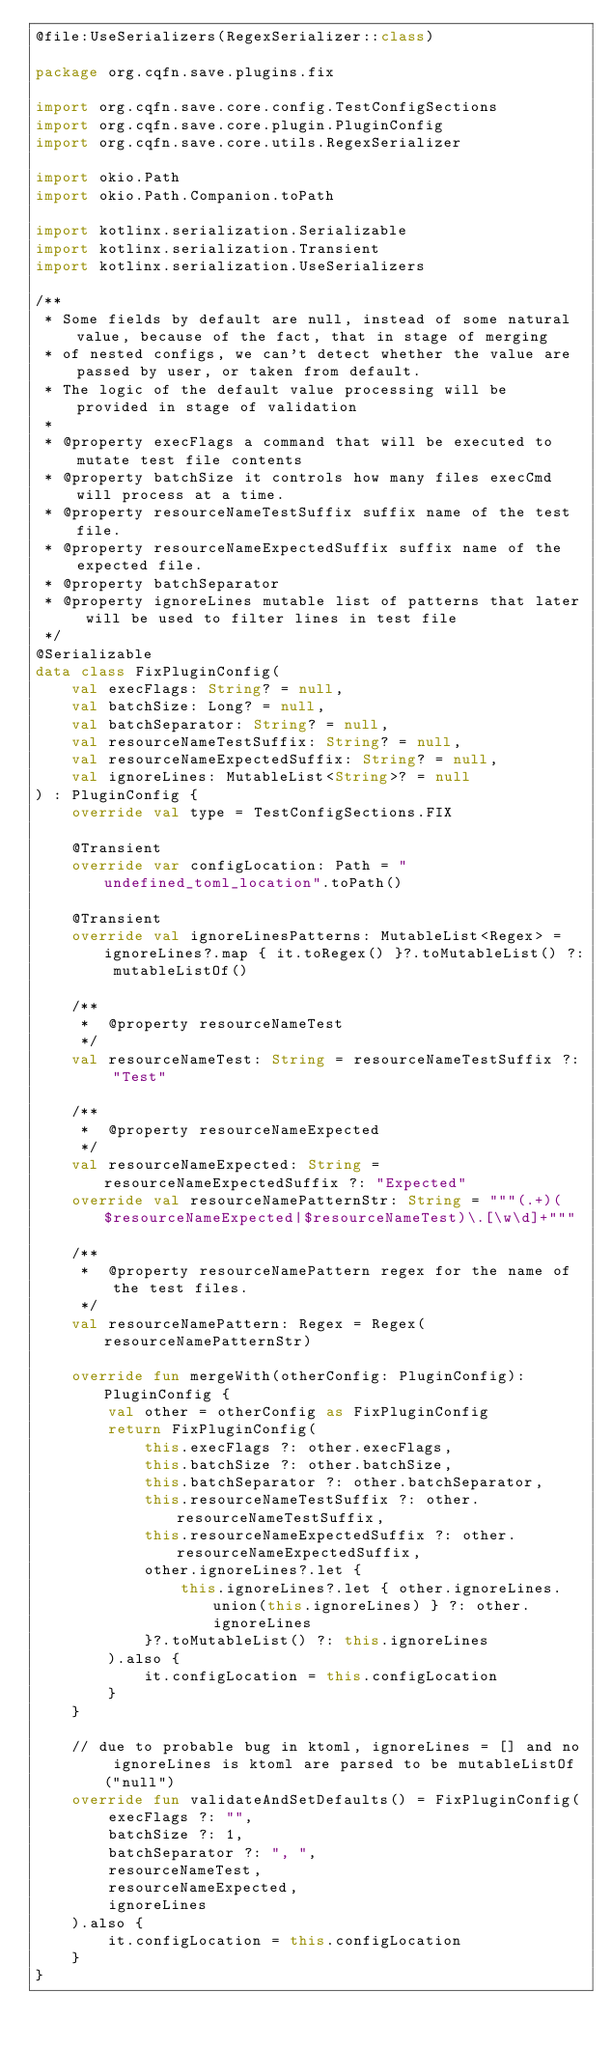<code> <loc_0><loc_0><loc_500><loc_500><_Kotlin_>@file:UseSerializers(RegexSerializer::class)

package org.cqfn.save.plugins.fix

import org.cqfn.save.core.config.TestConfigSections
import org.cqfn.save.core.plugin.PluginConfig
import org.cqfn.save.core.utils.RegexSerializer

import okio.Path
import okio.Path.Companion.toPath

import kotlinx.serialization.Serializable
import kotlinx.serialization.Transient
import kotlinx.serialization.UseSerializers

/**
 * Some fields by default are null, instead of some natural value, because of the fact, that in stage of merging
 * of nested configs, we can't detect whether the value are passed by user, or taken from default.
 * The logic of the default value processing will be provided in stage of validation
 *
 * @property execFlags a command that will be executed to mutate test file contents
 * @property batchSize it controls how many files execCmd will process at a time.
 * @property resourceNameTestSuffix suffix name of the test file.
 * @property resourceNameExpectedSuffix suffix name of the expected file.
 * @property batchSeparator
 * @property ignoreLines mutable list of patterns that later will be used to filter lines in test file
 */
@Serializable
data class FixPluginConfig(
    val execFlags: String? = null,
    val batchSize: Long? = null,
    val batchSeparator: String? = null,
    val resourceNameTestSuffix: String? = null,
    val resourceNameExpectedSuffix: String? = null,
    val ignoreLines: MutableList<String>? = null
) : PluginConfig {
    override val type = TestConfigSections.FIX

    @Transient
    override var configLocation: Path = "undefined_toml_location".toPath()

    @Transient
    override val ignoreLinesPatterns: MutableList<Regex> = ignoreLines?.map { it.toRegex() }?.toMutableList() ?: mutableListOf()

    /**
     *  @property resourceNameTest
     */
    val resourceNameTest: String = resourceNameTestSuffix ?: "Test"

    /**
     *  @property resourceNameExpected
     */
    val resourceNameExpected: String = resourceNameExpectedSuffix ?: "Expected"
    override val resourceNamePatternStr: String = """(.+)($resourceNameExpected|$resourceNameTest)\.[\w\d]+"""

    /**
     *  @property resourceNamePattern regex for the name of the test files.
     */
    val resourceNamePattern: Regex = Regex(resourceNamePatternStr)

    override fun mergeWith(otherConfig: PluginConfig): PluginConfig {
        val other = otherConfig as FixPluginConfig
        return FixPluginConfig(
            this.execFlags ?: other.execFlags,
            this.batchSize ?: other.batchSize,
            this.batchSeparator ?: other.batchSeparator,
            this.resourceNameTestSuffix ?: other.resourceNameTestSuffix,
            this.resourceNameExpectedSuffix ?: other.resourceNameExpectedSuffix,
            other.ignoreLines?.let {
                this.ignoreLines?.let { other.ignoreLines.union(this.ignoreLines) } ?: other.ignoreLines
            }?.toMutableList() ?: this.ignoreLines
        ).also {
            it.configLocation = this.configLocation
        }
    }

    // due to probable bug in ktoml, ignoreLines = [] and no ignoreLines is ktoml are parsed to be mutableListOf("null")
    override fun validateAndSetDefaults() = FixPluginConfig(
        execFlags ?: "",
        batchSize ?: 1,
        batchSeparator ?: ", ",
        resourceNameTest,
        resourceNameExpected,
        ignoreLines
    ).also {
        it.configLocation = this.configLocation
    }
}
</code> 